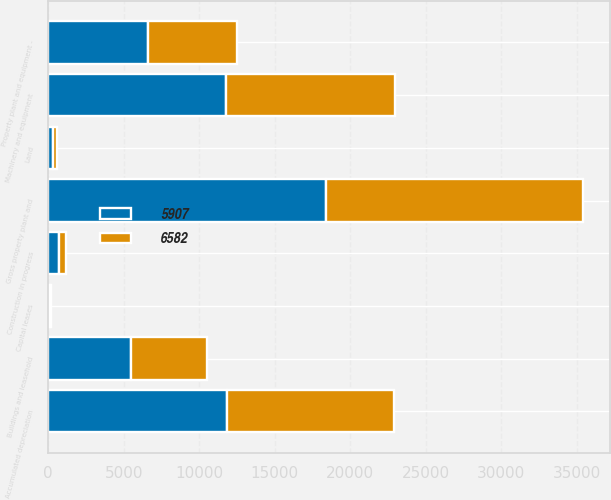Convert chart. <chart><loc_0><loc_0><loc_500><loc_500><stacked_bar_chart><ecel><fcel>Land<fcel>Buildings and leasehold<fcel>Machinery and equipment<fcel>Construction in progress<fcel>Capital leases<fcel>Gross property plant and<fcel>Accumulated depreciation<fcel>Property plant and equipment -<nl><fcel>5907<fcel>303<fcel>5496<fcel>11801<fcel>684<fcel>106<fcel>18390<fcel>11808<fcel>6582<nl><fcel>6582<fcel>281<fcel>5002<fcel>11130<fcel>505<fcel>99<fcel>17017<fcel>11110<fcel>5907<nl></chart> 